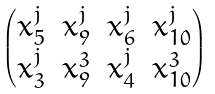<formula> <loc_0><loc_0><loc_500><loc_500>\begin{pmatrix} x _ { 5 } ^ { j } & x _ { 9 } ^ { j } & x _ { 6 } ^ { j } & x _ { 1 0 } ^ { j } \\ x _ { 3 } ^ { j } & x _ { 9 } ^ { 3 } & x _ { 4 } ^ { j } & x _ { 1 0 } ^ { 3 } \end{pmatrix}</formula> 